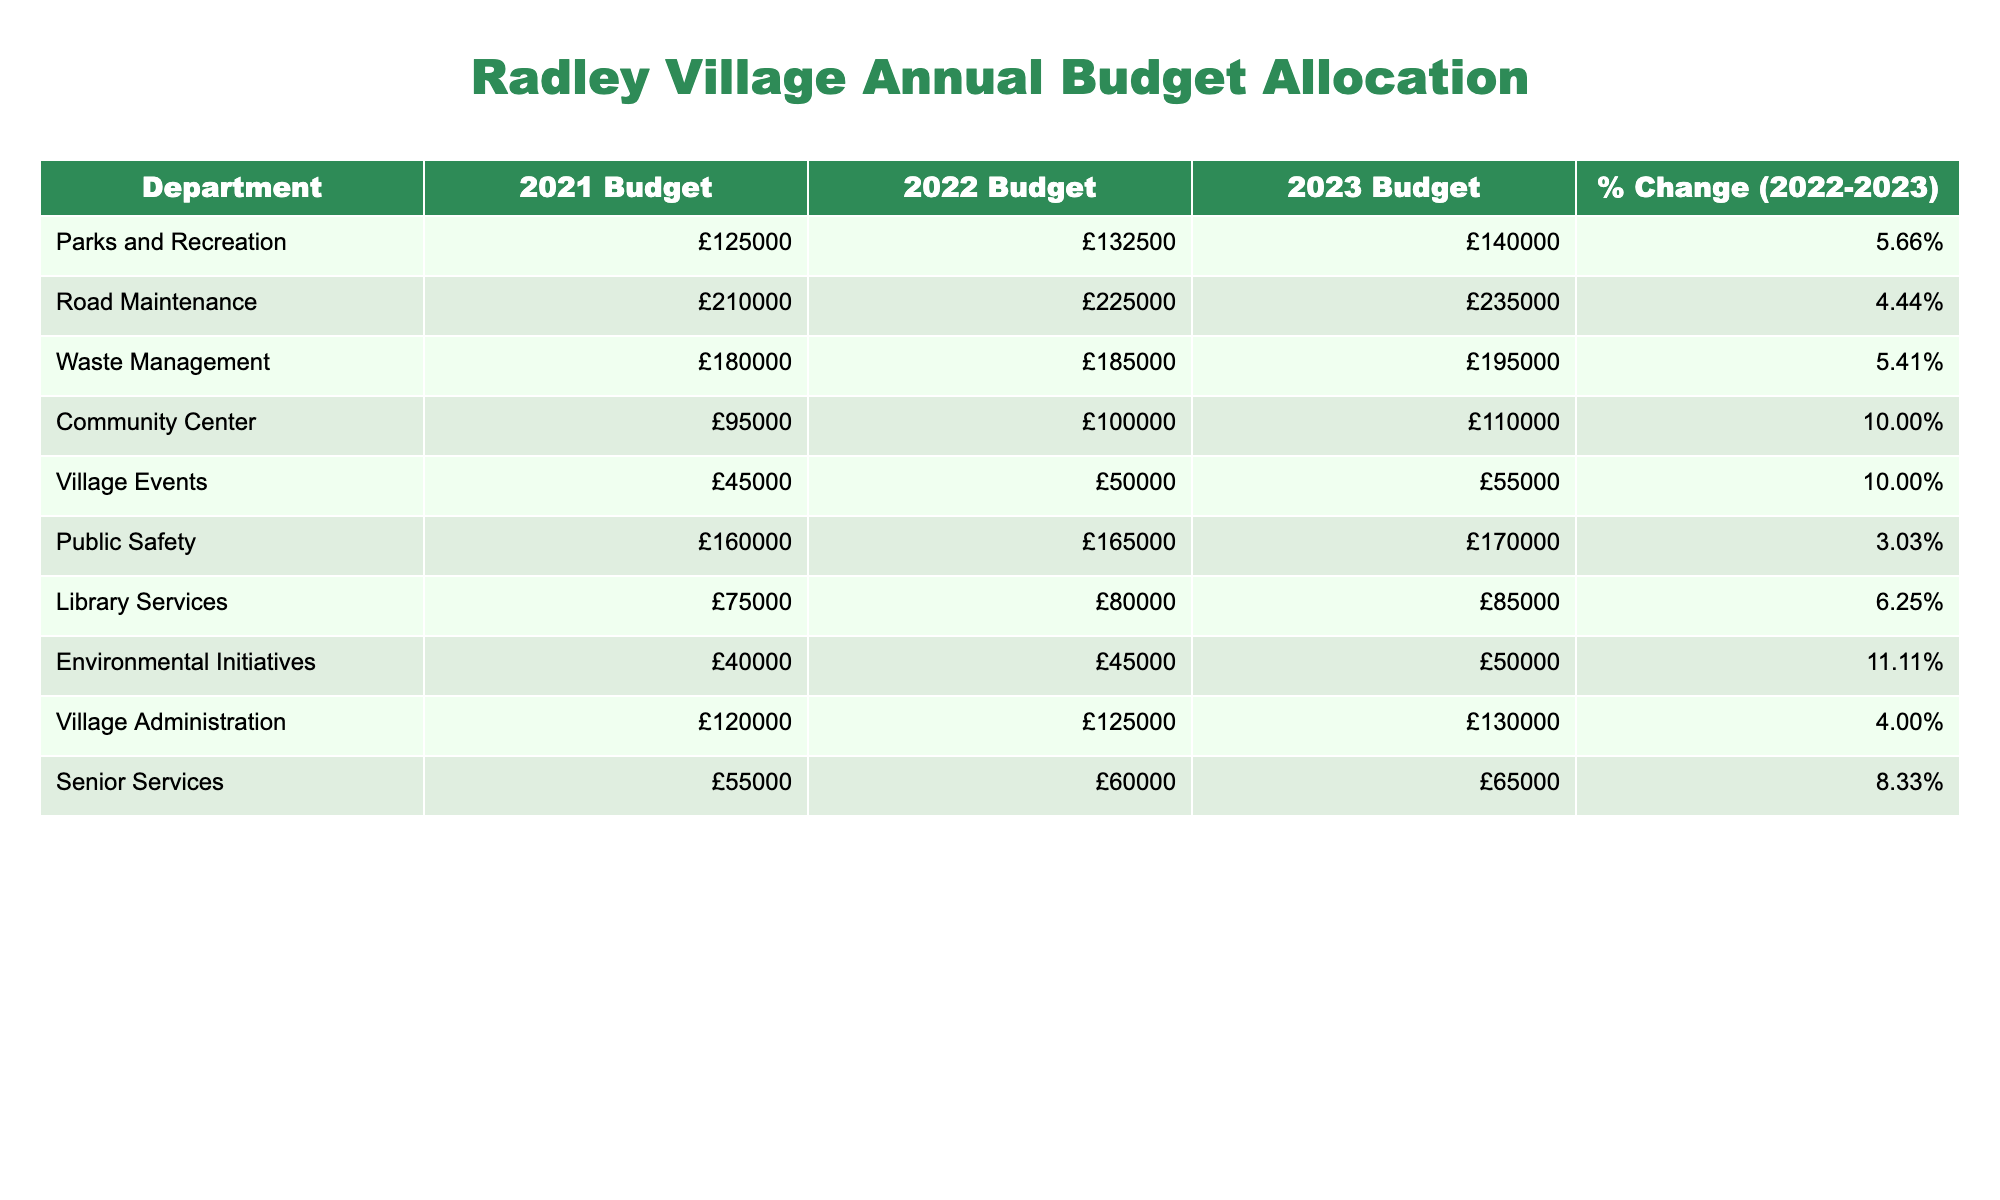What was the budget for the Community Center in 2023? The table shows that the budget allocated for the Community Center in 2023 is listed under that department, which is £110,000.
Answer: £110,000 Which department saw the highest percentage increase in budget from 2022 to 2023? The percentage changes for each department are compared; Environmental Initiatives had a 11.11% increase, the highest among all departments.
Answer: Environmental Initiatives What is the total budget allocation for Parks and Recreation and Waste Management in 2023? The budgets for Parks and Recreation and Waste Management in 2023 are £140,000 and £195,000, respectively. Adding these gives £140,000 + £195,000 = £335,000.
Answer: £335,000 Is the amount allocated to Village Events more than that of Senior Services in 2023? In 2023, Village Events received £55,000, while Senior Services received £65,000. Since £55,000 is less than £65,000, the statement is false.
Answer: No What was the overall percentage increase in budgets from 2021 to 2023 for Public Safety? The budget for Public Safety in 2021 was £160,000 and in 2023 it is £170,000. The increase is £170,000 - £160,000 = £10,000. To find the percentage increase, divide the increase by the original value: (£10,000 / £160,000) * 100 = 6.25%.
Answer: 6.25% How much more budget did Road Maintenance receive compared to Library Services in 2022? The budget for Road Maintenance in 2022 is £225,000, and for Library Services, it is £80,000. The difference is £225,000 - £80,000 = £145,000.
Answer: £145,000 Are the total budgets for Village Administration and Parks and Recreation in 2023 greater than £270,000? The budgets in 2023 are £130,000 for Village Administration and £140,000 for Parks and Recreation. Adding these gives £130,000 + £140,000 = £270,000, which is not greater than £270,000.
Answer: No What is the average budget allocation for all departments in 2023? To find the average, first sum all the 2023 budgets: £140,000 + £235,000 + £195,000 + £110,000 + £55,000 + £170,000 + £85,000 + £50,000 + £130,000 + £65,000 = £1,155,000. There are 10 departments, so the average is £1,155,000 / 10 = £115,500.
Answer: £115,500 Which department had a budget of exactly £180,000 in 2021? By checking the table, Waste Management had a budget of £180,000 in 2021.
Answer: Waste Management If the Community Center's budget were to increase by 15% in 2024, what would the new budget be? The budget for the Community Center in 2023 is £110,000. A 15% increase would be calculated as £110,000 * 0.15 = £16,500. Adding this to the original budget gives £110,000 + £16,500 = £126,500.
Answer: £126,500 